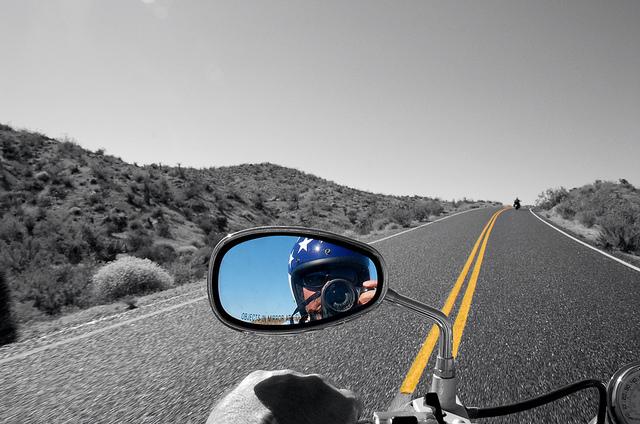What is on the man's helmet?
Be succinct. Stars. What vehicle is this person riding?
Answer briefly. Motorcycle. Is there a reflection?
Concise answer only. Yes. 